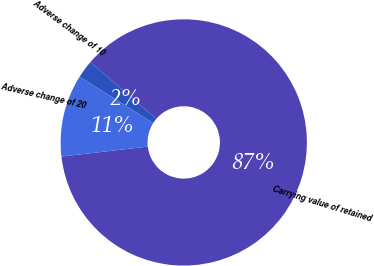Convert chart. <chart><loc_0><loc_0><loc_500><loc_500><pie_chart><fcel>Carrying value of retained<fcel>Adverse change of 10<fcel>Adverse change of 20<nl><fcel>86.87%<fcel>2.34%<fcel>10.79%<nl></chart> 